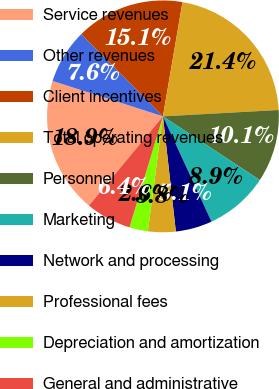<chart> <loc_0><loc_0><loc_500><loc_500><pie_chart><fcel>Service revenues<fcel>Other revenues<fcel>Client incentives<fcel>Total operating revenues<fcel>Personnel<fcel>Marketing<fcel>Network and processing<fcel>Professional fees<fcel>Depreciation and amortization<fcel>General and administrative<nl><fcel>18.92%<fcel>7.61%<fcel>15.15%<fcel>21.43%<fcel>10.13%<fcel>8.87%<fcel>5.1%<fcel>3.85%<fcel>2.59%<fcel>6.36%<nl></chart> 